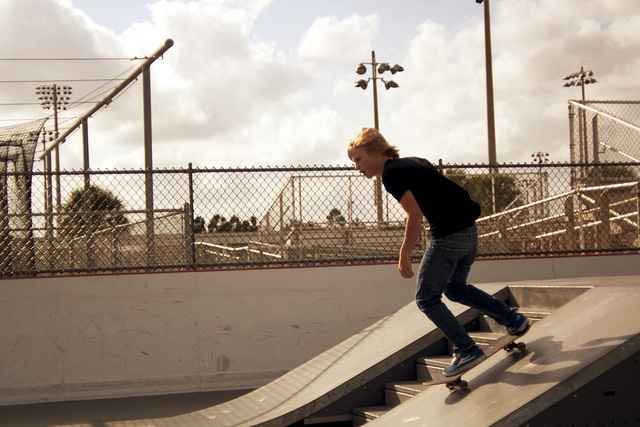Describe the objects in this image and their specific colors. I can see people in ivory, black, maroon, and gray tones and skateboard in ivory, gray, black, and maroon tones in this image. 